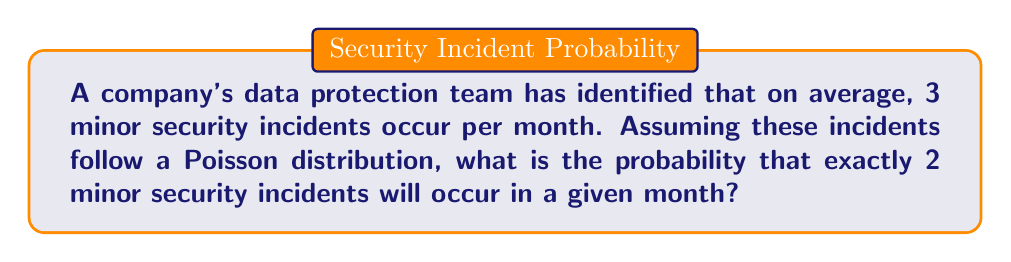Provide a solution to this math problem. To solve this problem, we'll use the Poisson distribution formula:

$$ P(X = k) = \frac{e^{-\lambda} \lambda^k}{k!} $$

Where:
- $\lambda$ is the average number of events in the given interval
- $k$ is the number of events we're interested in
- $e$ is Euler's number (approximately 2.71828)

Given:
- $\lambda = 3$ (average of 3 incidents per month)
- $k = 2$ (we're interested in exactly 2 incidents)

Let's substitute these values into the formula:

$$ P(X = 2) = \frac{e^{-3} 3^2}{2!} $$

Now, let's calculate step by step:

1) First, calculate $e^{-3}$:
   $e^{-3} \approx 0.0497$

2) Calculate $3^2$:
   $3^2 = 9$

3) Calculate $2!$:
   $2! = 2 \times 1 = 2$

4) Put it all together:
   $$ P(X = 2) = \frac{0.0497 \times 9}{2} = \frac{0.4473}{2} = 0.2237 $$

Therefore, the probability of exactly 2 minor security incidents occurring in a given month is approximately 0.2237 or 22.37%.
Answer: 0.2237 